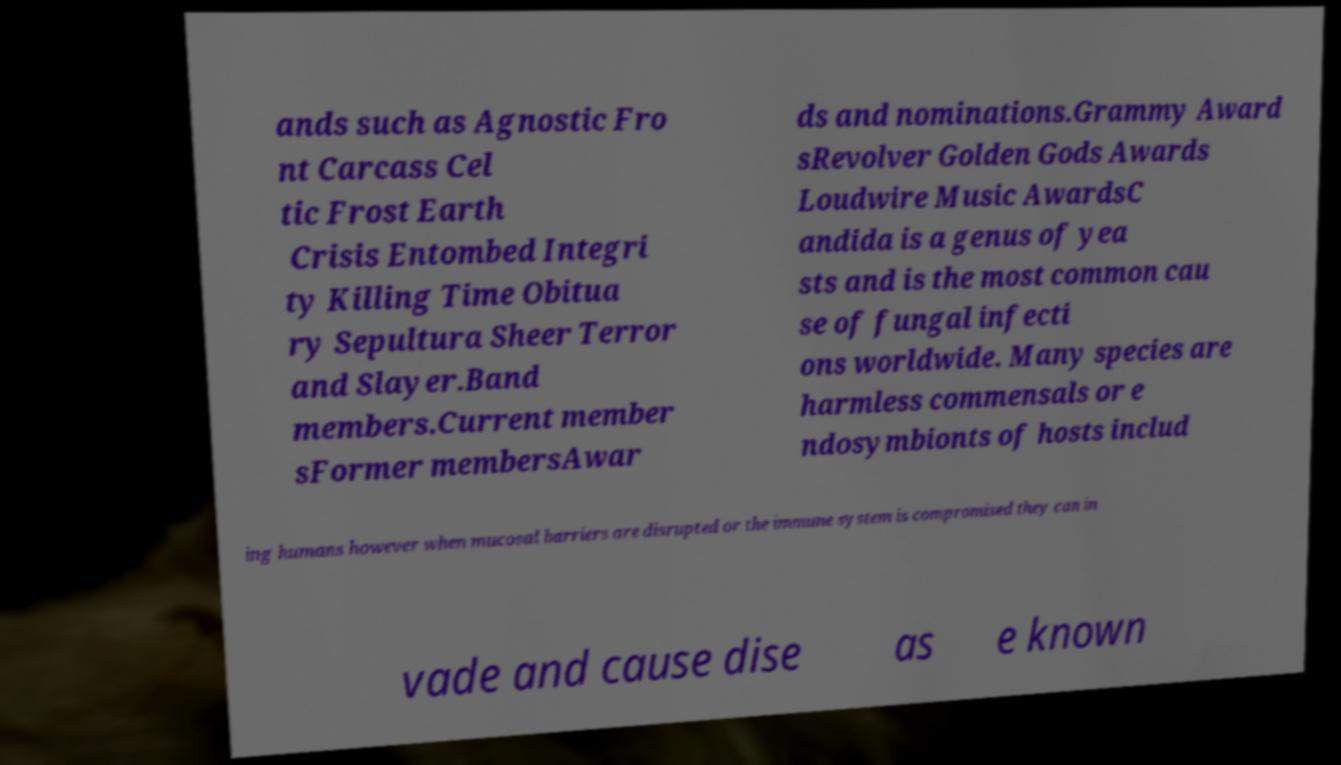What messages or text are displayed in this image? I need them in a readable, typed format. ands such as Agnostic Fro nt Carcass Cel tic Frost Earth Crisis Entombed Integri ty Killing Time Obitua ry Sepultura Sheer Terror and Slayer.Band members.Current member sFormer membersAwar ds and nominations.Grammy Award sRevolver Golden Gods Awards Loudwire Music AwardsC andida is a genus of yea sts and is the most common cau se of fungal infecti ons worldwide. Many species are harmless commensals or e ndosymbionts of hosts includ ing humans however when mucosal barriers are disrupted or the immune system is compromised they can in vade and cause dise as e known 